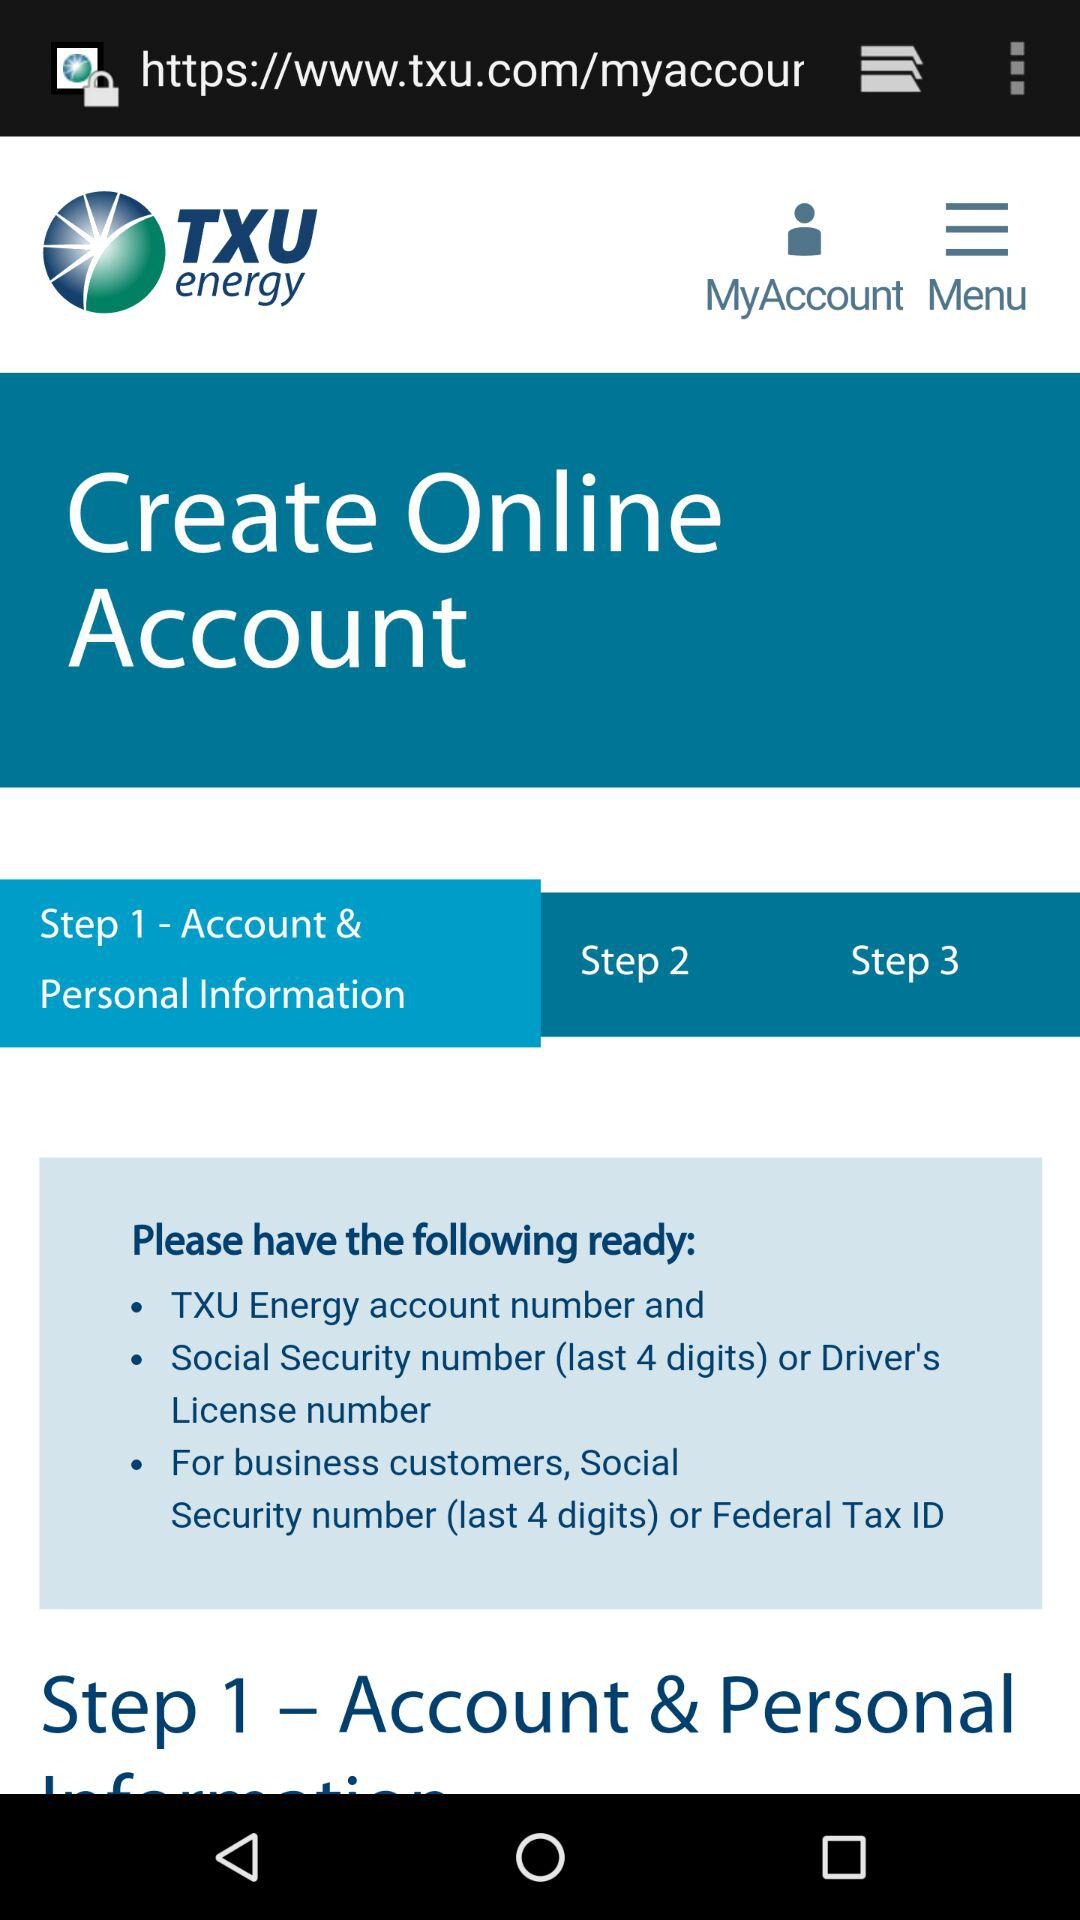How many steps are there in the account creation process?
Answer the question using a single word or phrase. 3 